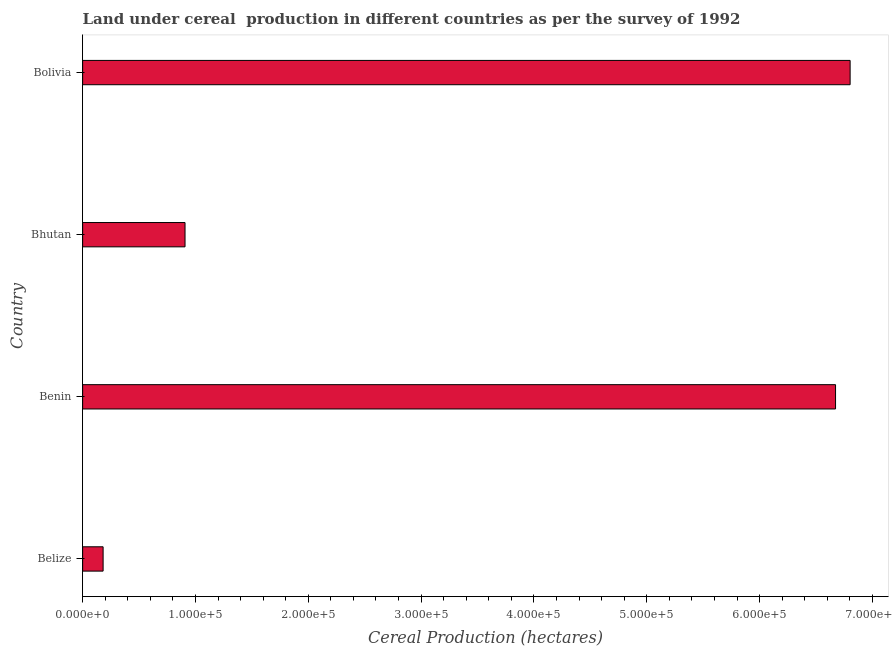Does the graph contain grids?
Give a very brief answer. No. What is the title of the graph?
Keep it short and to the point. Land under cereal  production in different countries as per the survey of 1992. What is the label or title of the X-axis?
Your response must be concise. Cereal Production (hectares). What is the label or title of the Y-axis?
Offer a terse response. Country. What is the land under cereal production in Bhutan?
Offer a terse response. 9.08e+04. Across all countries, what is the maximum land under cereal production?
Keep it short and to the point. 6.80e+05. Across all countries, what is the minimum land under cereal production?
Provide a succinct answer. 1.82e+04. In which country was the land under cereal production minimum?
Provide a succinct answer. Belize. What is the sum of the land under cereal production?
Your response must be concise. 1.46e+06. What is the difference between the land under cereal production in Belize and Bolivia?
Your answer should be very brief. -6.62e+05. What is the average land under cereal production per country?
Provide a succinct answer. 3.64e+05. What is the median land under cereal production?
Provide a short and direct response. 3.79e+05. In how many countries, is the land under cereal production greater than 280000 hectares?
Your answer should be compact. 2. What is the ratio of the land under cereal production in Bhutan to that in Bolivia?
Your response must be concise. 0.13. Is the land under cereal production in Benin less than that in Bhutan?
Provide a short and direct response. No. What is the difference between the highest and the second highest land under cereal production?
Offer a terse response. 1.29e+04. What is the difference between the highest and the lowest land under cereal production?
Offer a very short reply. 6.62e+05. How many bars are there?
Ensure brevity in your answer.  4. Are all the bars in the graph horizontal?
Offer a very short reply. Yes. How many countries are there in the graph?
Your response must be concise. 4. Are the values on the major ticks of X-axis written in scientific E-notation?
Offer a terse response. Yes. What is the Cereal Production (hectares) in Belize?
Provide a succinct answer. 1.82e+04. What is the Cereal Production (hectares) in Benin?
Keep it short and to the point. 6.67e+05. What is the Cereal Production (hectares) of Bhutan?
Your response must be concise. 9.08e+04. What is the Cereal Production (hectares) in Bolivia?
Provide a succinct answer. 6.80e+05. What is the difference between the Cereal Production (hectares) in Belize and Benin?
Your answer should be very brief. -6.49e+05. What is the difference between the Cereal Production (hectares) in Belize and Bhutan?
Provide a short and direct response. -7.26e+04. What is the difference between the Cereal Production (hectares) in Belize and Bolivia?
Offer a very short reply. -6.62e+05. What is the difference between the Cereal Production (hectares) in Benin and Bhutan?
Your response must be concise. 5.77e+05. What is the difference between the Cereal Production (hectares) in Benin and Bolivia?
Your response must be concise. -1.29e+04. What is the difference between the Cereal Production (hectares) in Bhutan and Bolivia?
Your answer should be very brief. -5.89e+05. What is the ratio of the Cereal Production (hectares) in Belize to that in Benin?
Your response must be concise. 0.03. What is the ratio of the Cereal Production (hectares) in Belize to that in Bolivia?
Provide a short and direct response. 0.03. What is the ratio of the Cereal Production (hectares) in Benin to that in Bhutan?
Your response must be concise. 7.35. What is the ratio of the Cereal Production (hectares) in Benin to that in Bolivia?
Your answer should be very brief. 0.98. What is the ratio of the Cereal Production (hectares) in Bhutan to that in Bolivia?
Give a very brief answer. 0.13. 